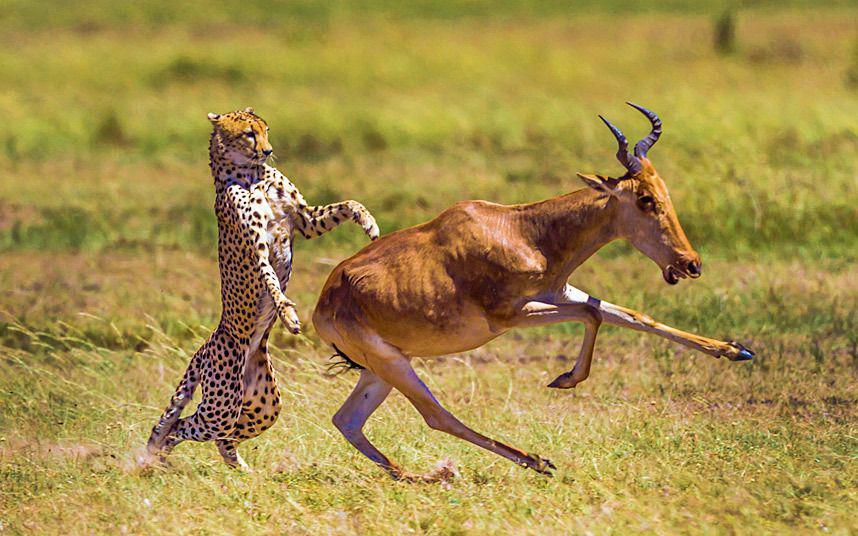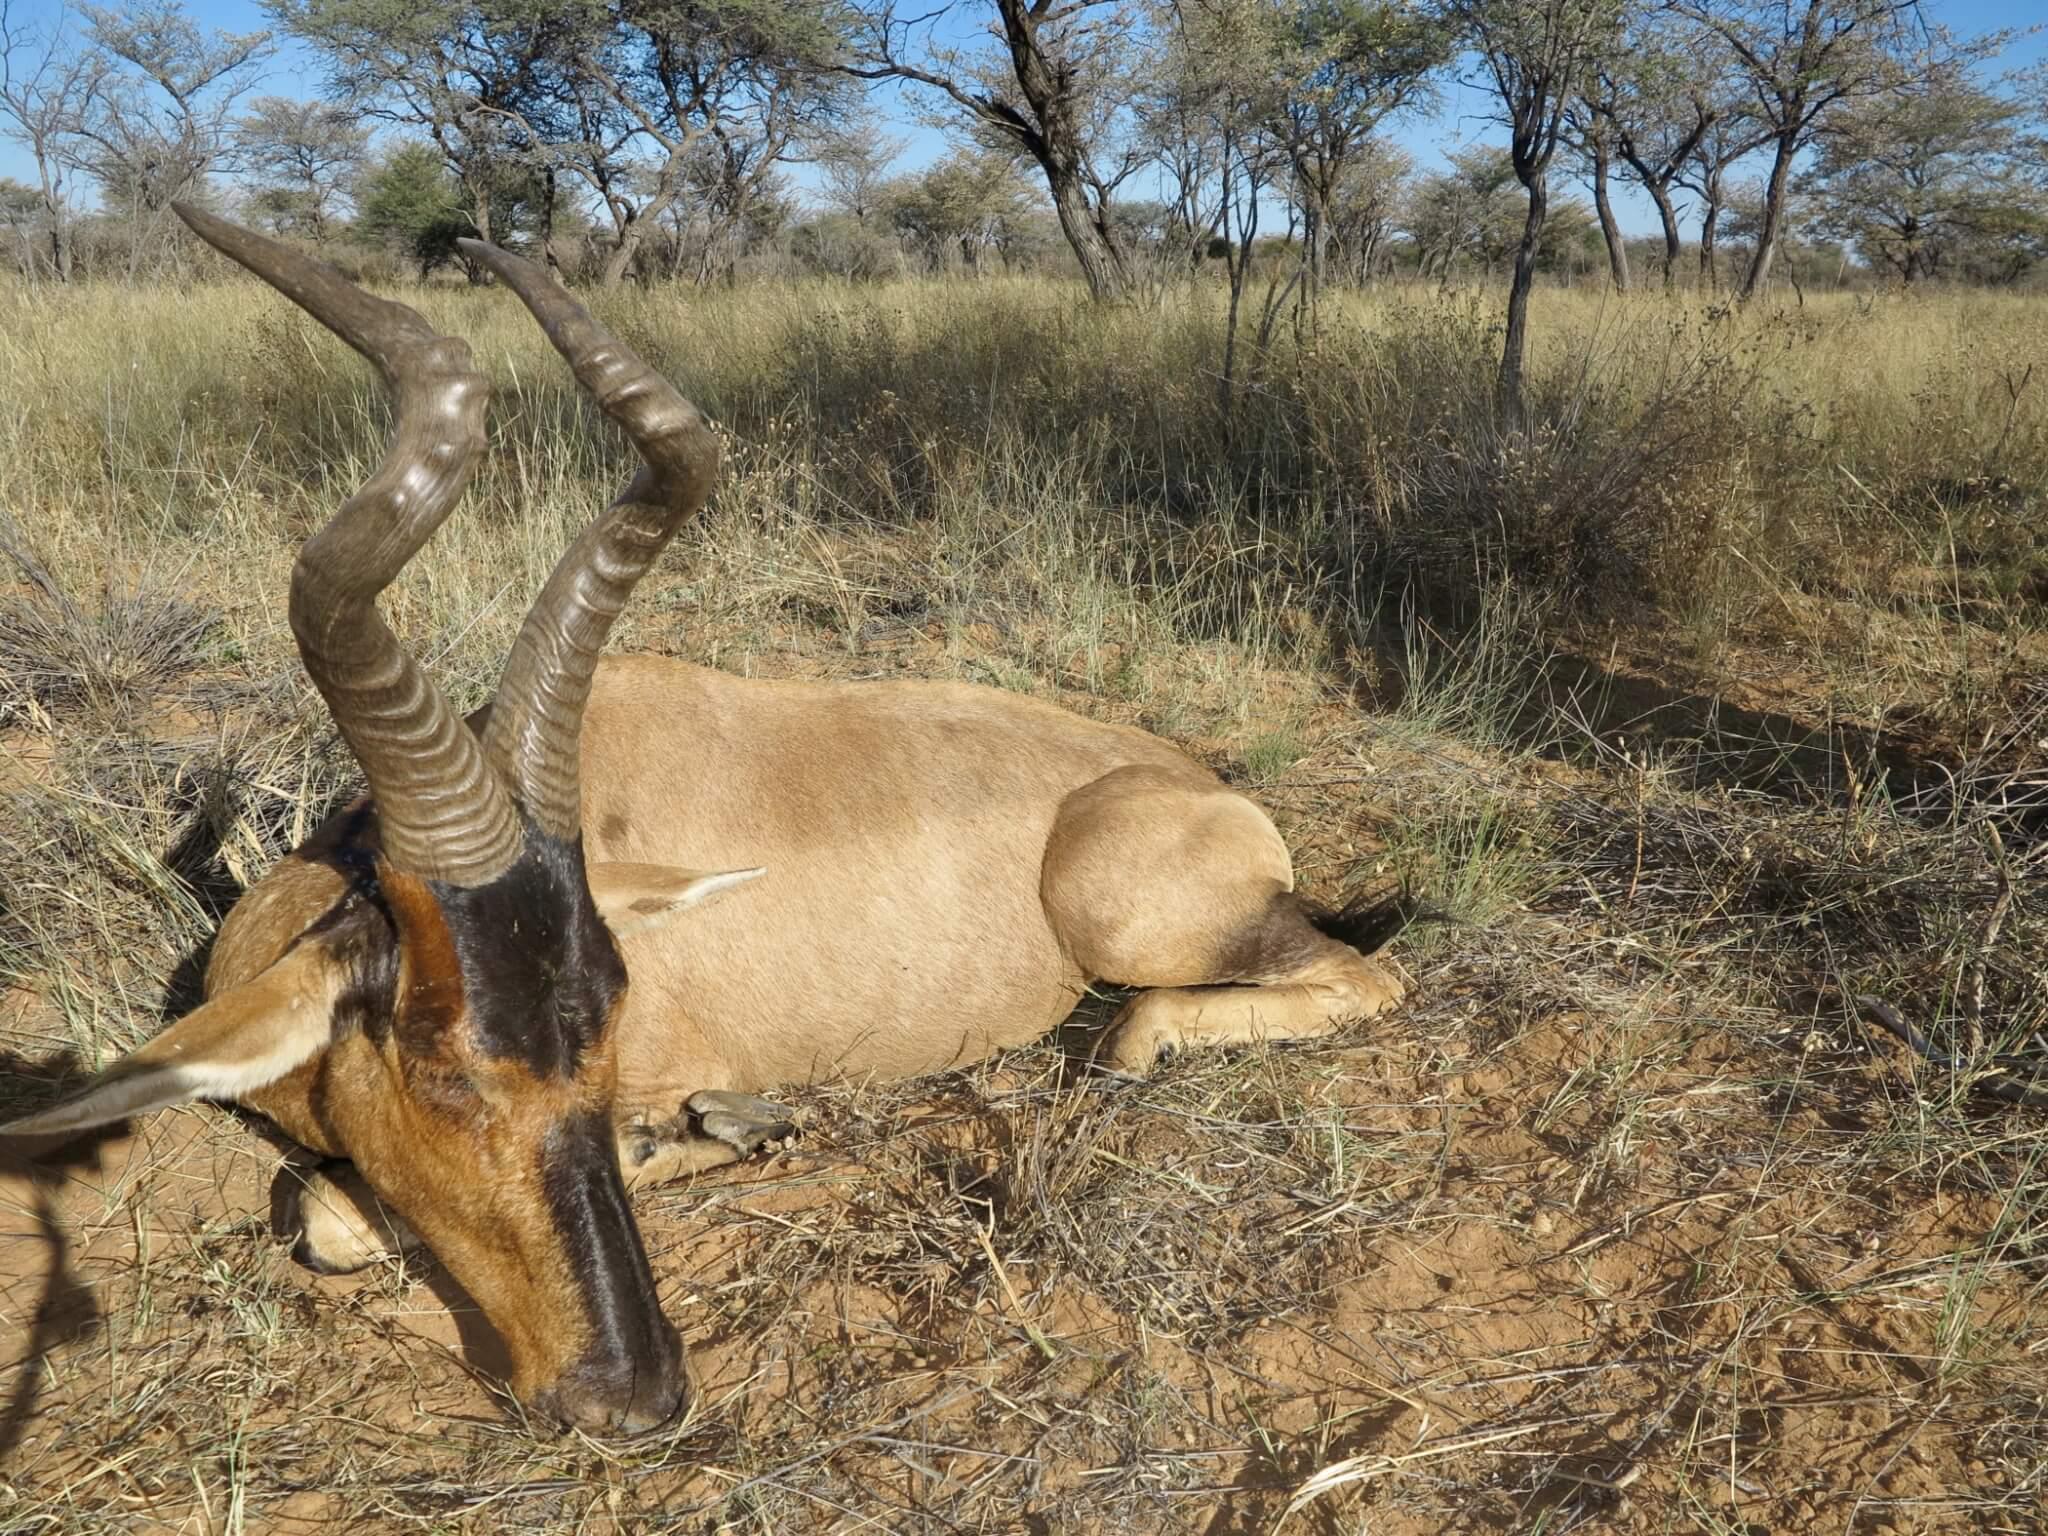The first image is the image on the left, the second image is the image on the right. Assess this claim about the two images: "Exactly one animal is lying on the ground.". Correct or not? Answer yes or no. Yes. The first image is the image on the left, the second image is the image on the right. Evaluate the accuracy of this statement regarding the images: "In one image, a hunter in a hat holding a rifle vertically is behind a downed horned animal with its head to the right.". Is it true? Answer yes or no. No. 